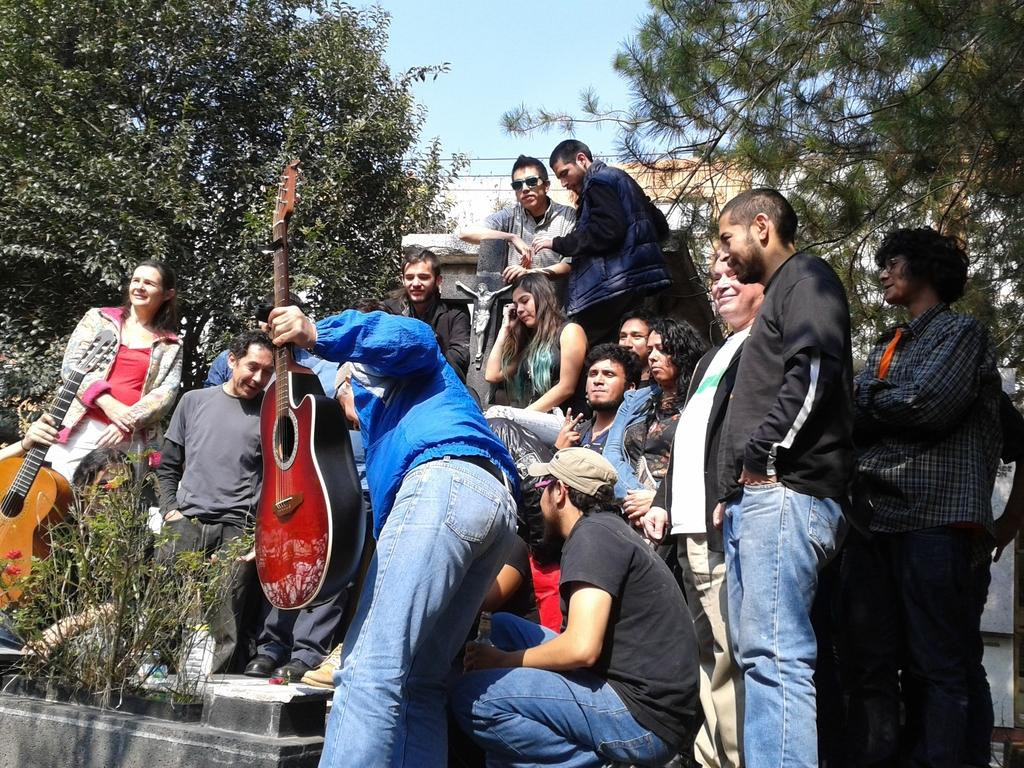What is the person in the image doing? The person is holding a guitar. What is the person wearing in the image? The person is wearing a blue shirt. How many people can be seen in the background of the image? There are many people in the background of the image. What type of vegetation is visible in the background of the image? There are trees in the background of the image. What is visible in the sky in the background of the image? The sky is visible in the background of the image. What type of thumb is being used to play the guitar in the image? There is no specific thumb being highlighted in the image; the person is simply holding the guitar. 